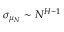Convert formula to latex. <formula><loc_0><loc_0><loc_500><loc_500>\sigma _ { \mu _ { N } } \sim N ^ { H - 1 }</formula> 